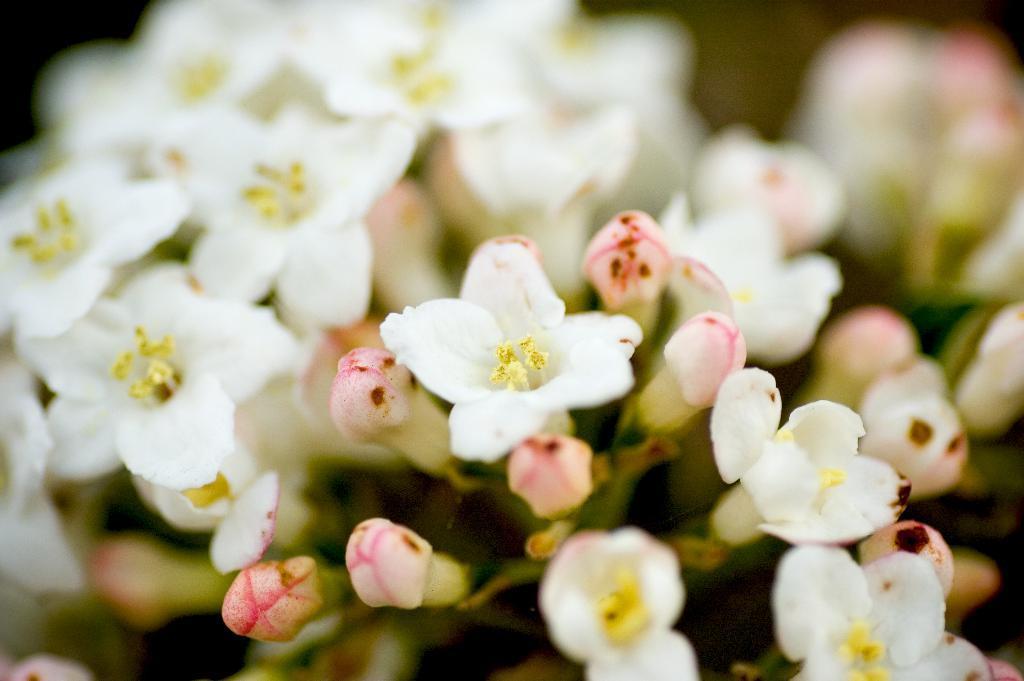Describe this image in one or two sentences. In this image we can see white flowers. Background it is blur. 